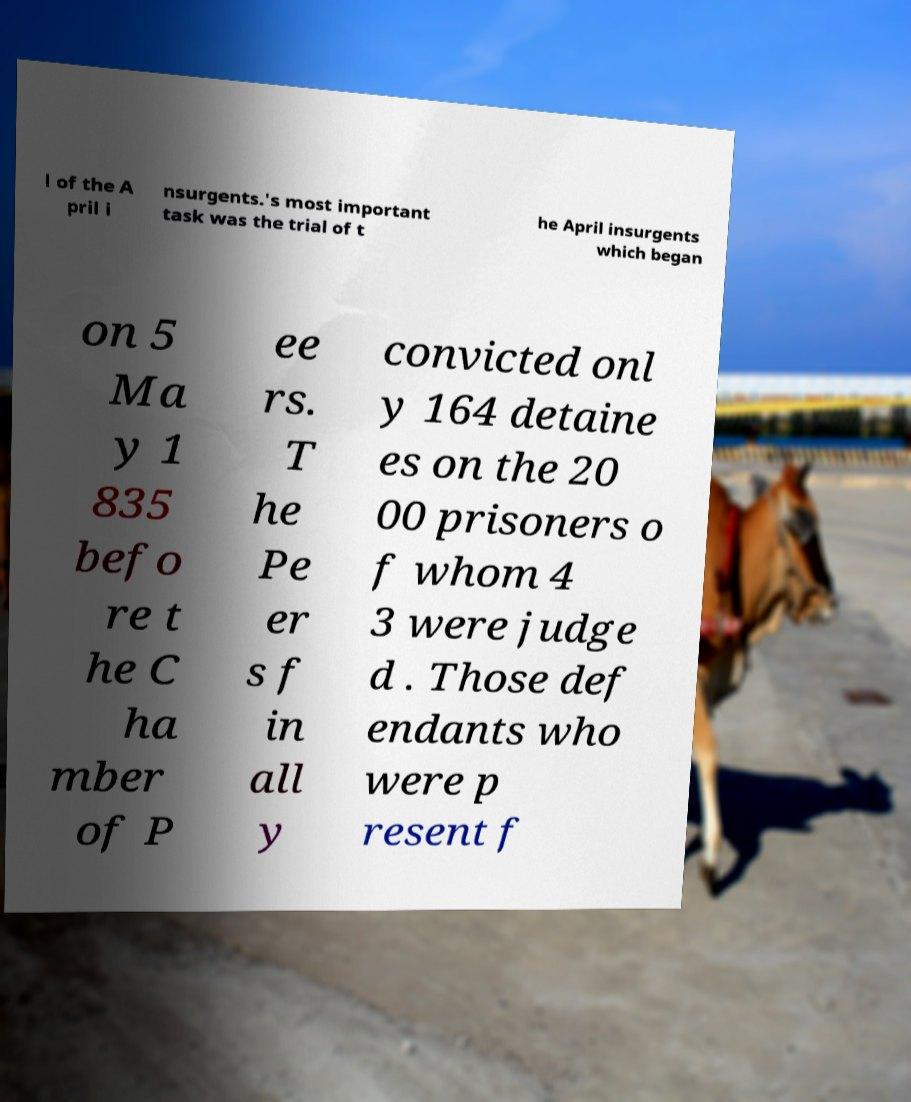Can you accurately transcribe the text from the provided image for me? l of the A pril i nsurgents.'s most important task was the trial of t he April insurgents which began on 5 Ma y 1 835 befo re t he C ha mber of P ee rs. T he Pe er s f in all y convicted onl y 164 detaine es on the 20 00 prisoners o f whom 4 3 were judge d . Those def endants who were p resent f 